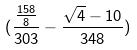Convert formula to latex. <formula><loc_0><loc_0><loc_500><loc_500>( \frac { \frac { 1 5 8 } { 8 } } { 3 0 3 } - \frac { \sqrt { 4 } - 1 0 } { 3 4 8 } )</formula> 